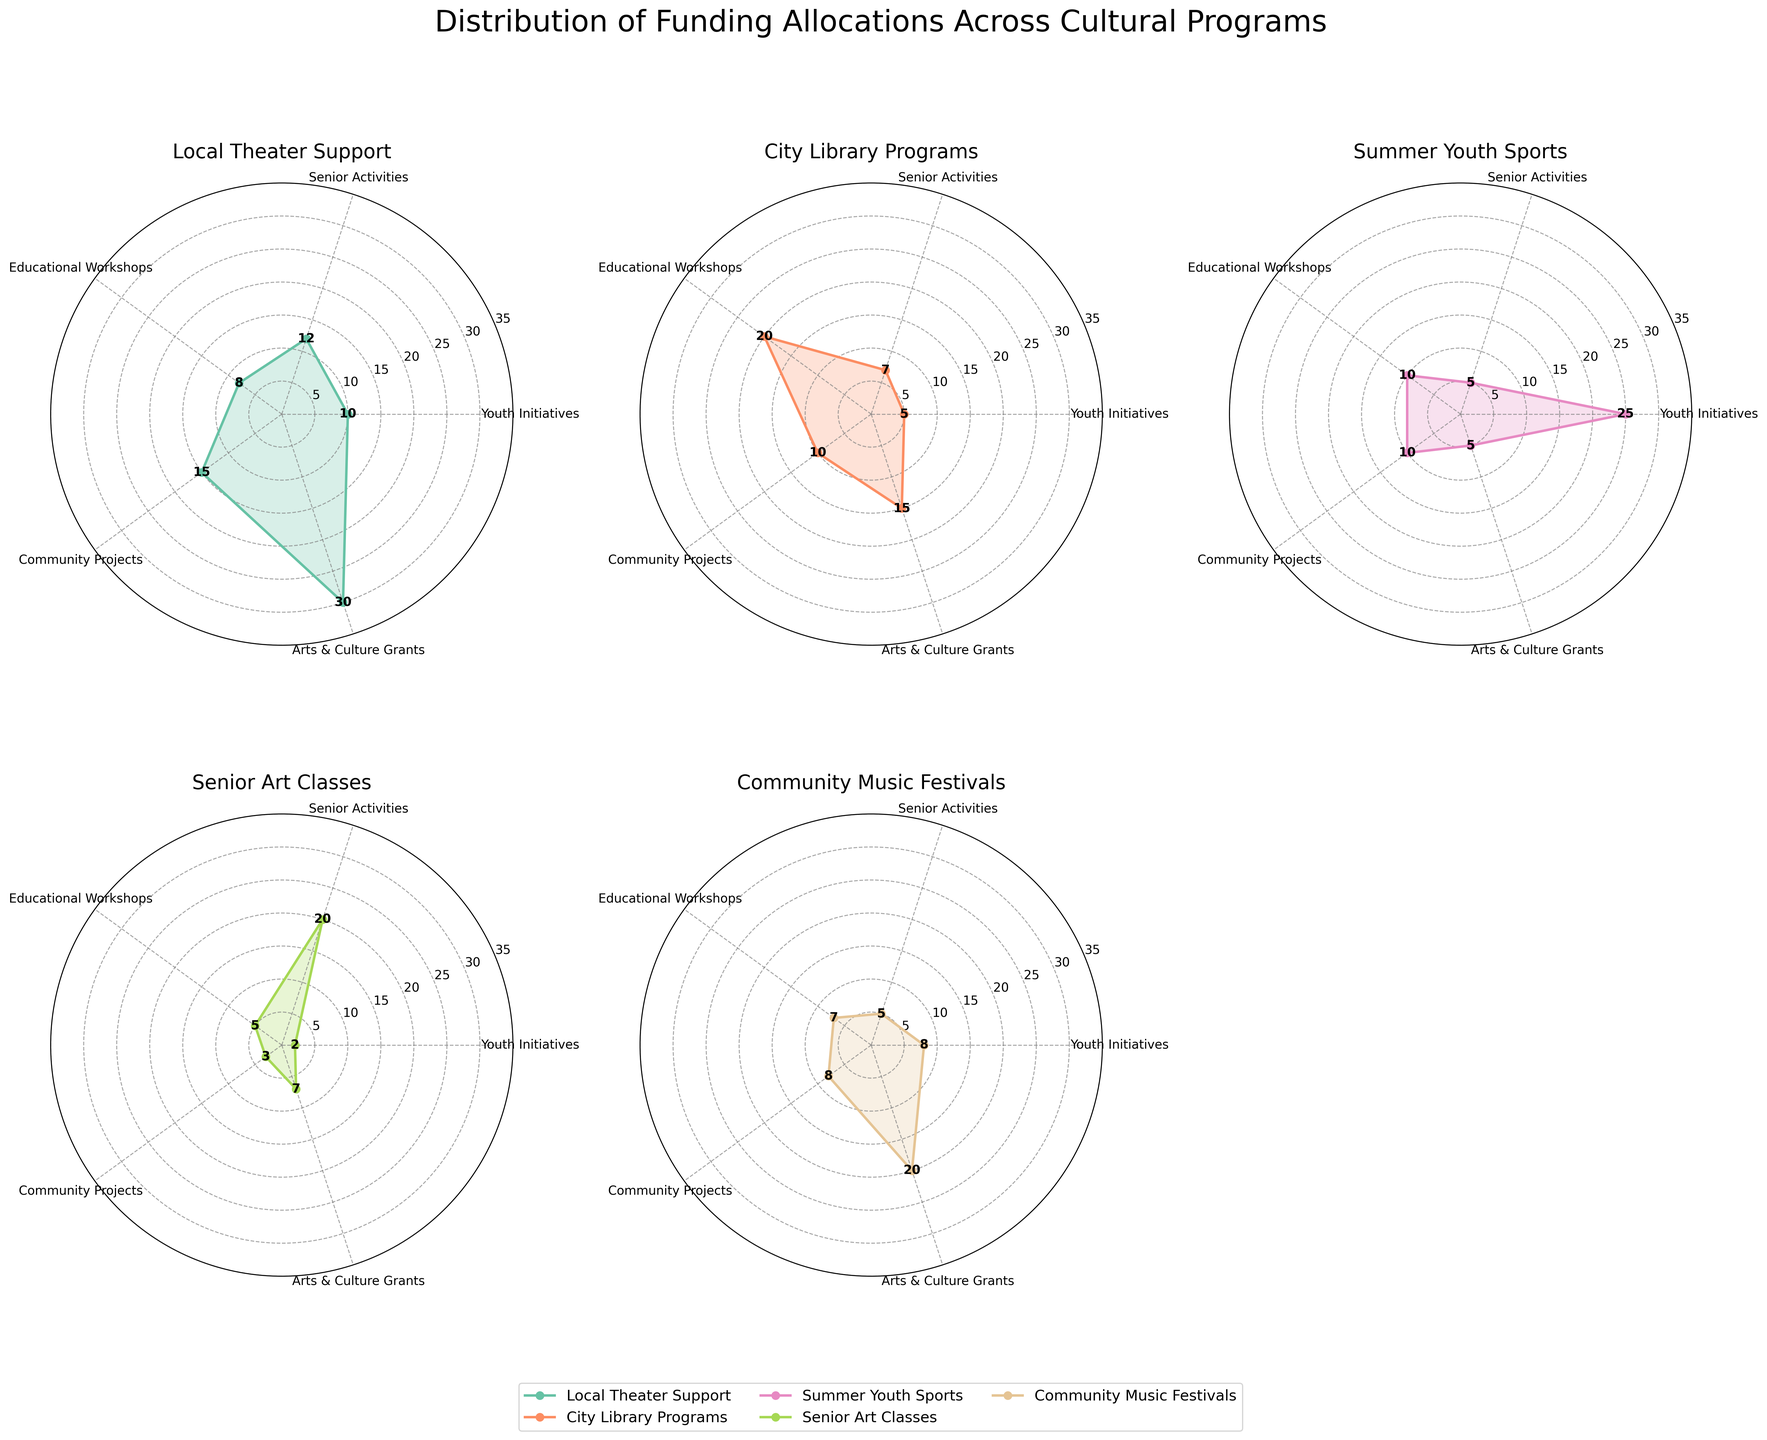Which program received the highest funding for Arts & Culture Grants? By observing the 'Arts & Culture Grants' points in the radar subplots and comparing them, we see that the 'Local Theater Support' program has the highest point, indicated at 30 units, which is the highest among the plotted data for this category.
Answer: Local Theater Support How much more funding does Summer Youth Sports receive in Youth Initiatives than Senior Art Classes? In the 'Youth Initiatives' category, 'Summer Youth Sports' receives 25 units, and 'Senior Art Classes' receives 2 units. The difference is calculated as 25 - 2 = 23.
Answer: 23 Which program has the highest average funding across all categories? By calculating the average funding for each program: 
- Local Theater Support: (10+12+8+15+30)/5 = 15 
- City Library Programs: (5+7+20+10+15)/5 = 11.4 
- Summer Youth Sports: (25+5+10+10+5)/5 = 11 
- Senior Art Classes: (2+20+5+3+7)/5 = 7.4 
- Community Music Festivals: (8+5+7+8+20)/5 = 9.6 
- Neighborhood Improvement: (10+8+12+30+5)/5 = 13, 
Thus, Local Theater Support has the highest average funding.
Answer: Local Theater Support Which programs receive equal funding in Community Projects? Observing the radar subplots for 'Community Projects,' 'Local Theater Support' and 'Summer Youth Sports' both point to 10 units.
Answer: Local Theater Support, Summer Youth Sports What is the total funding for Senior Activities across all programs? Adding the 'Senior Activities' funding from all programs: 12 (Local Theater Support) + 7 (City Library Programs) + 5 (Summer Youth Sports) + 20 (Senior Art Classes) + 5 (Community Music Festivals) + 8 (Neighborhood Improvement), the total is 57 units.
Answer: 57 Which program has the smallest variability in funding across the categories? To determine variability, we can visually inspect which radar chart has the most uniform shape and the smallest range of funding values:
- Local Theater Support has a range from 8 to 30,
- City Library Programs from 5 to 20,
- Summer Youth Sports from 5 to 25,
- Senior Art Classes from 2 to 20,
- Community Music Festivals from 5 to 20,
- Neighborhood Improvement from 5 to 30. 
City Library Programs have the smallest range of 15 (20 - 5).
Answer: City Library Programs 